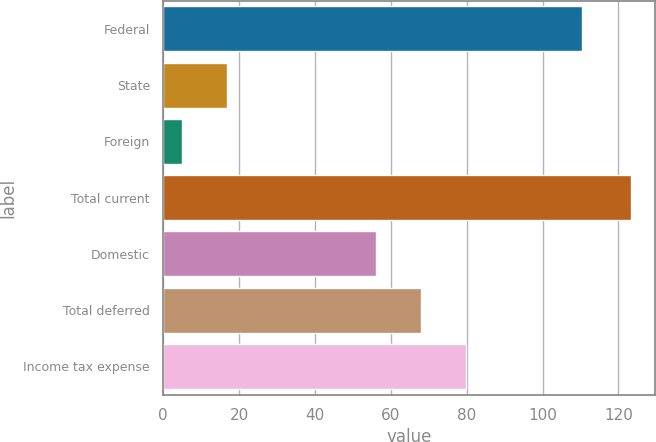Convert chart to OTSL. <chart><loc_0><loc_0><loc_500><loc_500><bar_chart><fcel>Federal<fcel>State<fcel>Foreign<fcel>Total current<fcel>Domestic<fcel>Total deferred<fcel>Income tax expense<nl><fcel>110.3<fcel>16.93<fcel>5.1<fcel>123.4<fcel>56.2<fcel>68.03<fcel>79.86<nl></chart> 